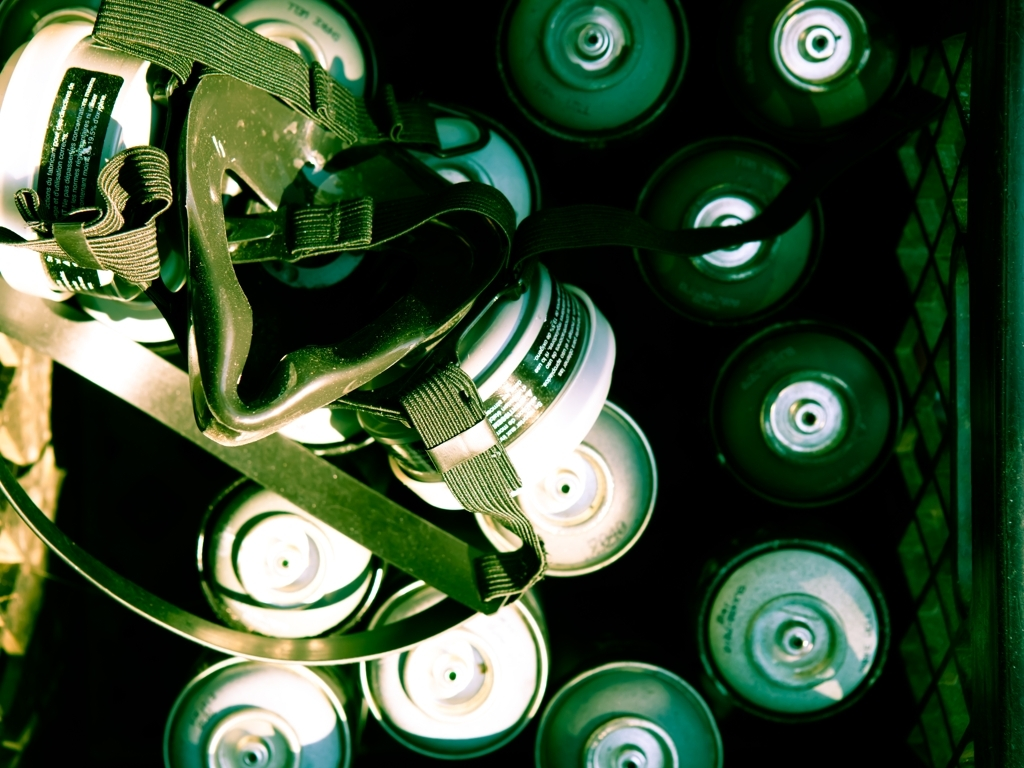Are the texture details clear and visible? Yes, the texture details are clear and visible. The image showcases a close-up view of spray cans and what appears to be the strap of a respirator, emphasizing the fine textures with distinct contrast and sharp details. The metallic sheen of the can tops and the woven texture of the strap are particularly noticeable. 